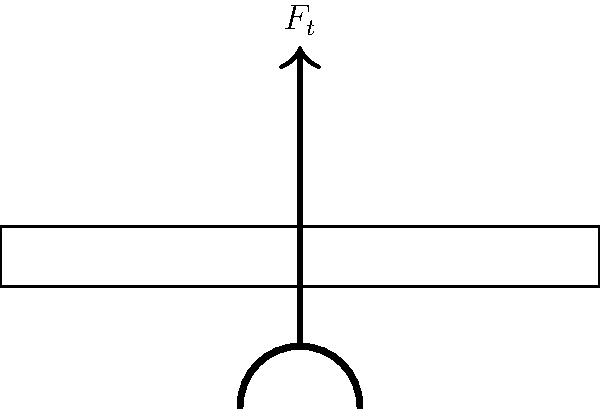In martial arts, breaking boards is a common demonstration of power and technique. Consider a karateka striking a wooden board with their hand. The total force applied by the hand can be decomposed into two components: a tangential force $F_t$ parallel to the board's surface, and a normal force $F_n$ perpendicular to the board's surface. If the total force applied is 500 N at an angle of 30° from the vertical, calculate the magnitude of the normal force $F_n$ acting on the board. Round your answer to the nearest whole number. To solve this problem, we'll follow these steps:

1) First, let's visualize the force components:
   - $F_t$ is the tangential force (parallel to the board)
   - $F_n$ is the normal force (perpendicular to the board)
   - The total force $F$ is at a 30° angle from the vertical

2) We know that the total force $F = 500$ N

3) To find $F_n$, we need to use trigonometry. The normal force is adjacent to the 30° angle in the right triangle formed by the force components.

4) We can use the cosine function to relate $F_n$ to $F$:

   $$F_n = F \cos(30°)$$

5) Now, let's substitute the values:

   $$F_n = 500 \cos(30°)$$

6) Calculate:
   $$F_n = 500 \times \frac{\sqrt{3}}{2} \approx 433.01 \text{ N}$$

7) Rounding to the nearest whole number:
   $$F_n \approx 433 \text{ N}$$

Therefore, the magnitude of the normal force acting on the board is approximately 433 N.
Answer: 433 N 